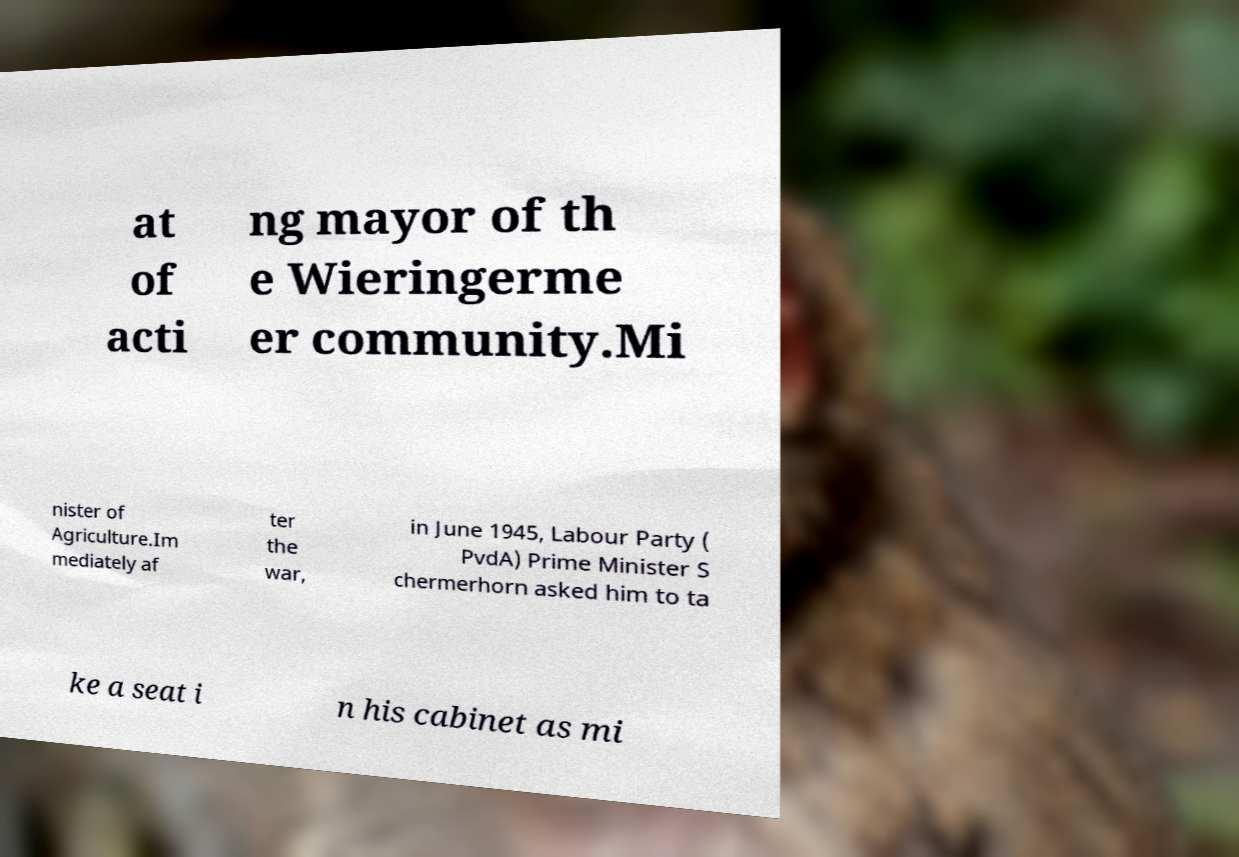Could you assist in decoding the text presented in this image and type it out clearly? at of acti ng mayor of th e Wieringerme er community.Mi nister of Agriculture.Im mediately af ter the war, in June 1945, Labour Party ( PvdA) Prime Minister S chermerhorn asked him to ta ke a seat i n his cabinet as mi 